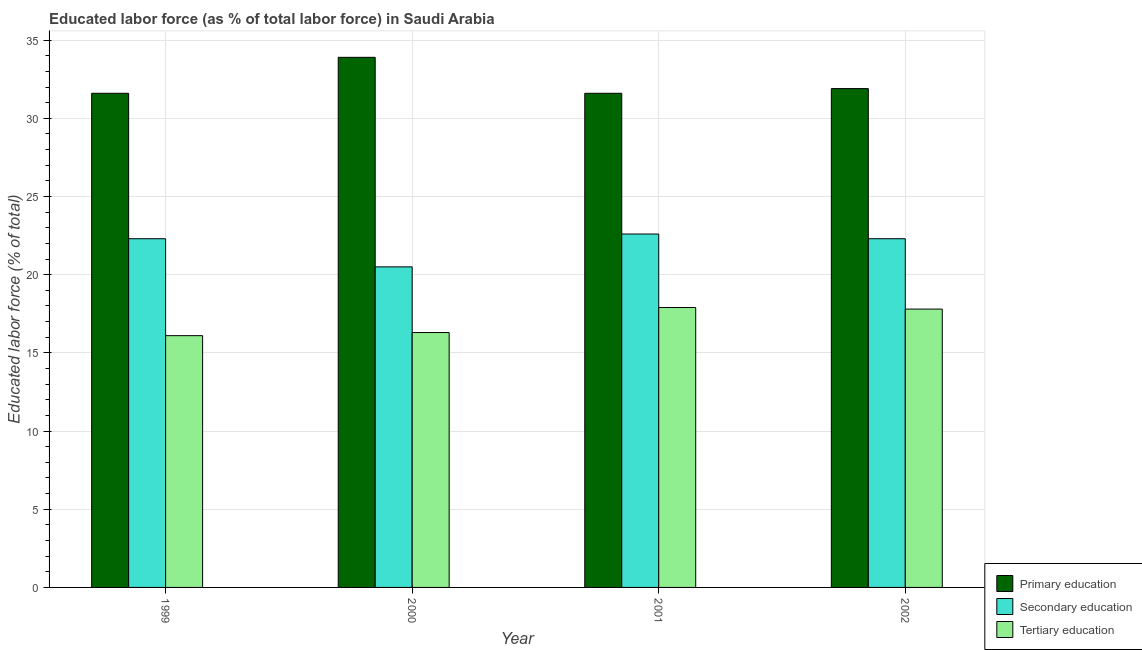How many different coloured bars are there?
Offer a terse response. 3. Are the number of bars on each tick of the X-axis equal?
Make the answer very short. Yes. What is the label of the 3rd group of bars from the left?
Your answer should be compact. 2001. In how many cases, is the number of bars for a given year not equal to the number of legend labels?
Make the answer very short. 0. What is the percentage of labor force who received primary education in 2001?
Your answer should be compact. 31.6. Across all years, what is the maximum percentage of labor force who received tertiary education?
Provide a succinct answer. 17.9. Across all years, what is the minimum percentage of labor force who received secondary education?
Ensure brevity in your answer.  20.5. In which year was the percentage of labor force who received tertiary education maximum?
Your answer should be very brief. 2001. What is the total percentage of labor force who received primary education in the graph?
Your answer should be compact. 129. What is the difference between the percentage of labor force who received tertiary education in 1999 and that in 2002?
Give a very brief answer. -1.7. What is the difference between the percentage of labor force who received secondary education in 2001 and the percentage of labor force who received tertiary education in 2002?
Ensure brevity in your answer.  0.3. What is the average percentage of labor force who received tertiary education per year?
Provide a succinct answer. 17.02. In the year 2002, what is the difference between the percentage of labor force who received secondary education and percentage of labor force who received primary education?
Ensure brevity in your answer.  0. In how many years, is the percentage of labor force who received secondary education greater than 15 %?
Offer a terse response. 4. What is the ratio of the percentage of labor force who received tertiary education in 1999 to that in 2000?
Provide a succinct answer. 0.99. What is the difference between the highest and the second highest percentage of labor force who received secondary education?
Make the answer very short. 0.3. What is the difference between the highest and the lowest percentage of labor force who received primary education?
Your response must be concise. 2.3. In how many years, is the percentage of labor force who received primary education greater than the average percentage of labor force who received primary education taken over all years?
Keep it short and to the point. 1. What does the 3rd bar from the left in 2001 represents?
Ensure brevity in your answer.  Tertiary education. What does the 2nd bar from the right in 2002 represents?
Offer a terse response. Secondary education. How many bars are there?
Your answer should be compact. 12. Are the values on the major ticks of Y-axis written in scientific E-notation?
Your response must be concise. No. Where does the legend appear in the graph?
Your response must be concise. Bottom right. How many legend labels are there?
Ensure brevity in your answer.  3. How are the legend labels stacked?
Your response must be concise. Vertical. What is the title of the graph?
Give a very brief answer. Educated labor force (as % of total labor force) in Saudi Arabia. Does "Spain" appear as one of the legend labels in the graph?
Give a very brief answer. No. What is the label or title of the Y-axis?
Offer a terse response. Educated labor force (% of total). What is the Educated labor force (% of total) of Primary education in 1999?
Your response must be concise. 31.6. What is the Educated labor force (% of total) of Secondary education in 1999?
Offer a very short reply. 22.3. What is the Educated labor force (% of total) in Tertiary education in 1999?
Ensure brevity in your answer.  16.1. What is the Educated labor force (% of total) of Primary education in 2000?
Provide a short and direct response. 33.9. What is the Educated labor force (% of total) in Tertiary education in 2000?
Ensure brevity in your answer.  16.3. What is the Educated labor force (% of total) of Primary education in 2001?
Make the answer very short. 31.6. What is the Educated labor force (% of total) in Secondary education in 2001?
Make the answer very short. 22.6. What is the Educated labor force (% of total) of Tertiary education in 2001?
Your answer should be compact. 17.9. What is the Educated labor force (% of total) in Primary education in 2002?
Provide a short and direct response. 31.9. What is the Educated labor force (% of total) of Secondary education in 2002?
Ensure brevity in your answer.  22.3. What is the Educated labor force (% of total) of Tertiary education in 2002?
Give a very brief answer. 17.8. Across all years, what is the maximum Educated labor force (% of total) of Primary education?
Your answer should be compact. 33.9. Across all years, what is the maximum Educated labor force (% of total) of Secondary education?
Ensure brevity in your answer.  22.6. Across all years, what is the maximum Educated labor force (% of total) in Tertiary education?
Provide a succinct answer. 17.9. Across all years, what is the minimum Educated labor force (% of total) of Primary education?
Offer a very short reply. 31.6. Across all years, what is the minimum Educated labor force (% of total) of Secondary education?
Offer a very short reply. 20.5. Across all years, what is the minimum Educated labor force (% of total) of Tertiary education?
Your response must be concise. 16.1. What is the total Educated labor force (% of total) of Primary education in the graph?
Your answer should be very brief. 129. What is the total Educated labor force (% of total) of Secondary education in the graph?
Your answer should be compact. 87.7. What is the total Educated labor force (% of total) in Tertiary education in the graph?
Give a very brief answer. 68.1. What is the difference between the Educated labor force (% of total) in Primary education in 1999 and that in 2000?
Your answer should be compact. -2.3. What is the difference between the Educated labor force (% of total) of Tertiary education in 1999 and that in 2000?
Keep it short and to the point. -0.2. What is the difference between the Educated labor force (% of total) in Secondary education in 1999 and that in 2001?
Offer a very short reply. -0.3. What is the difference between the Educated labor force (% of total) in Tertiary education in 1999 and that in 2001?
Your response must be concise. -1.8. What is the difference between the Educated labor force (% of total) in Primary education in 1999 and that in 2002?
Give a very brief answer. -0.3. What is the difference between the Educated labor force (% of total) of Secondary education in 1999 and that in 2002?
Provide a succinct answer. 0. What is the difference between the Educated labor force (% of total) of Secondary education in 2000 and that in 2001?
Make the answer very short. -2.1. What is the difference between the Educated labor force (% of total) in Tertiary education in 2000 and that in 2001?
Provide a succinct answer. -1.6. What is the difference between the Educated labor force (% of total) in Primary education in 2000 and that in 2002?
Your answer should be very brief. 2. What is the difference between the Educated labor force (% of total) in Tertiary education in 2000 and that in 2002?
Provide a succinct answer. -1.5. What is the difference between the Educated labor force (% of total) in Primary education in 2001 and that in 2002?
Give a very brief answer. -0.3. What is the difference between the Educated labor force (% of total) of Tertiary education in 2001 and that in 2002?
Give a very brief answer. 0.1. What is the difference between the Educated labor force (% of total) in Primary education in 1999 and the Educated labor force (% of total) in Tertiary education in 2000?
Provide a short and direct response. 15.3. What is the difference between the Educated labor force (% of total) in Secondary education in 1999 and the Educated labor force (% of total) in Tertiary education in 2000?
Your answer should be compact. 6. What is the difference between the Educated labor force (% of total) in Primary education in 1999 and the Educated labor force (% of total) in Tertiary education in 2001?
Your response must be concise. 13.7. What is the difference between the Educated labor force (% of total) in Secondary education in 1999 and the Educated labor force (% of total) in Tertiary education in 2001?
Offer a terse response. 4.4. What is the difference between the Educated labor force (% of total) in Primary education in 1999 and the Educated labor force (% of total) in Secondary education in 2002?
Provide a short and direct response. 9.3. What is the difference between the Educated labor force (% of total) in Primary education in 1999 and the Educated labor force (% of total) in Tertiary education in 2002?
Provide a short and direct response. 13.8. What is the difference between the Educated labor force (% of total) of Secondary education in 1999 and the Educated labor force (% of total) of Tertiary education in 2002?
Offer a very short reply. 4.5. What is the difference between the Educated labor force (% of total) in Primary education in 2000 and the Educated labor force (% of total) in Secondary education in 2001?
Ensure brevity in your answer.  11.3. What is the difference between the Educated labor force (% of total) of Primary education in 2000 and the Educated labor force (% of total) of Tertiary education in 2002?
Make the answer very short. 16.1. What is the difference between the Educated labor force (% of total) in Secondary education in 2000 and the Educated labor force (% of total) in Tertiary education in 2002?
Give a very brief answer. 2.7. What is the difference between the Educated labor force (% of total) of Secondary education in 2001 and the Educated labor force (% of total) of Tertiary education in 2002?
Provide a succinct answer. 4.8. What is the average Educated labor force (% of total) of Primary education per year?
Keep it short and to the point. 32.25. What is the average Educated labor force (% of total) of Secondary education per year?
Provide a succinct answer. 21.93. What is the average Educated labor force (% of total) of Tertiary education per year?
Provide a succinct answer. 17.02. In the year 1999, what is the difference between the Educated labor force (% of total) in Primary education and Educated labor force (% of total) in Secondary education?
Keep it short and to the point. 9.3. In the year 1999, what is the difference between the Educated labor force (% of total) in Secondary education and Educated labor force (% of total) in Tertiary education?
Provide a succinct answer. 6.2. In the year 2000, what is the difference between the Educated labor force (% of total) of Primary education and Educated labor force (% of total) of Secondary education?
Your answer should be very brief. 13.4. In the year 2001, what is the difference between the Educated labor force (% of total) of Primary education and Educated labor force (% of total) of Tertiary education?
Your answer should be very brief. 13.7. In the year 2002, what is the difference between the Educated labor force (% of total) in Primary education and Educated labor force (% of total) in Tertiary education?
Provide a succinct answer. 14.1. In the year 2002, what is the difference between the Educated labor force (% of total) of Secondary education and Educated labor force (% of total) of Tertiary education?
Your answer should be very brief. 4.5. What is the ratio of the Educated labor force (% of total) of Primary education in 1999 to that in 2000?
Your response must be concise. 0.93. What is the ratio of the Educated labor force (% of total) in Secondary education in 1999 to that in 2000?
Make the answer very short. 1.09. What is the ratio of the Educated labor force (% of total) of Secondary education in 1999 to that in 2001?
Offer a terse response. 0.99. What is the ratio of the Educated labor force (% of total) in Tertiary education in 1999 to that in 2001?
Make the answer very short. 0.9. What is the ratio of the Educated labor force (% of total) in Primary education in 1999 to that in 2002?
Offer a terse response. 0.99. What is the ratio of the Educated labor force (% of total) in Secondary education in 1999 to that in 2002?
Give a very brief answer. 1. What is the ratio of the Educated labor force (% of total) in Tertiary education in 1999 to that in 2002?
Offer a terse response. 0.9. What is the ratio of the Educated labor force (% of total) of Primary education in 2000 to that in 2001?
Your response must be concise. 1.07. What is the ratio of the Educated labor force (% of total) in Secondary education in 2000 to that in 2001?
Give a very brief answer. 0.91. What is the ratio of the Educated labor force (% of total) of Tertiary education in 2000 to that in 2001?
Ensure brevity in your answer.  0.91. What is the ratio of the Educated labor force (% of total) of Primary education in 2000 to that in 2002?
Keep it short and to the point. 1.06. What is the ratio of the Educated labor force (% of total) of Secondary education in 2000 to that in 2002?
Your answer should be very brief. 0.92. What is the ratio of the Educated labor force (% of total) of Tertiary education in 2000 to that in 2002?
Offer a very short reply. 0.92. What is the ratio of the Educated labor force (% of total) of Primary education in 2001 to that in 2002?
Offer a very short reply. 0.99. What is the ratio of the Educated labor force (% of total) in Secondary education in 2001 to that in 2002?
Give a very brief answer. 1.01. What is the ratio of the Educated labor force (% of total) of Tertiary education in 2001 to that in 2002?
Keep it short and to the point. 1.01. What is the difference between the highest and the second highest Educated labor force (% of total) of Primary education?
Offer a terse response. 2. What is the difference between the highest and the lowest Educated labor force (% of total) of Secondary education?
Offer a terse response. 2.1. What is the difference between the highest and the lowest Educated labor force (% of total) of Tertiary education?
Your response must be concise. 1.8. 